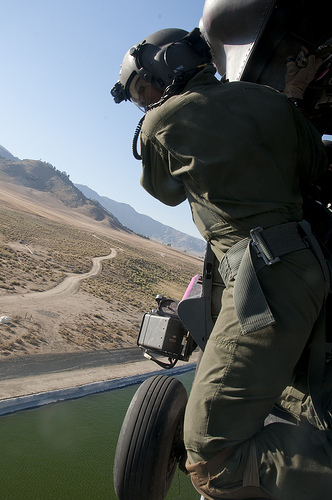<image>
Is there a wheel on the water? No. The wheel is not positioned on the water. They may be near each other, but the wheel is not supported by or resting on top of the water. 